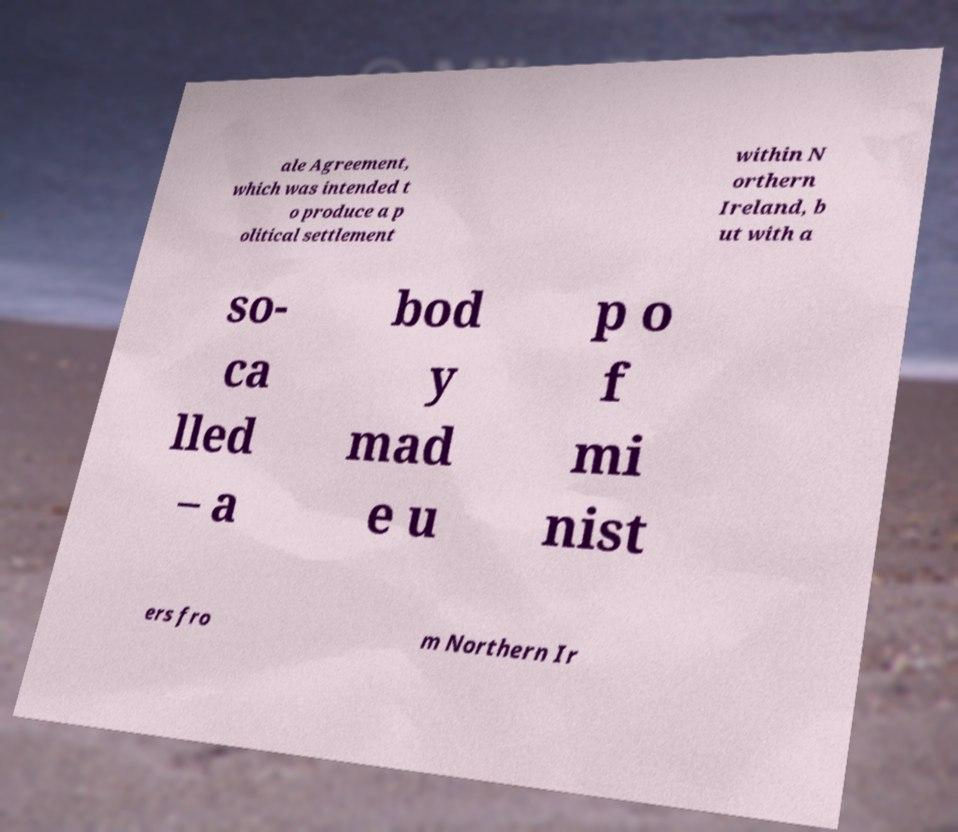Can you accurately transcribe the text from the provided image for me? ale Agreement, which was intended t o produce a p olitical settlement within N orthern Ireland, b ut with a so- ca lled – a bod y mad e u p o f mi nist ers fro m Northern Ir 